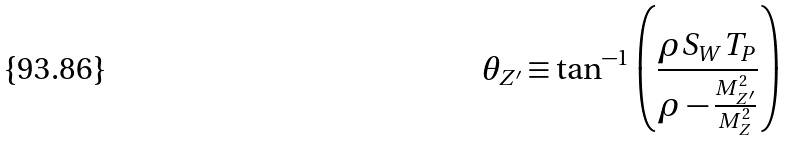<formula> <loc_0><loc_0><loc_500><loc_500>\theta _ { Z ^ { \prime } } \equiv \tan ^ { - 1 } \left ( \frac { \rho S _ { W } T _ { P } } { \rho - \frac { M _ { Z ^ { \prime } } ^ { 2 } } { M _ { Z } ^ { 2 } } } \right )</formula> 